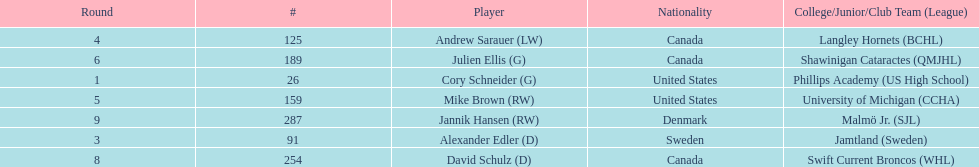Which round did not include a draft pick for the first time? 2. 